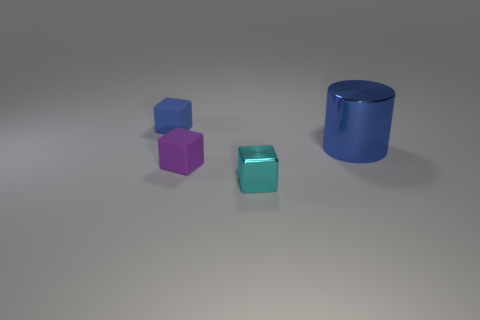The shiny thing that is to the right of the cyan shiny block has what shape?
Keep it short and to the point. Cylinder. Are there any other things that have the same material as the purple object?
Give a very brief answer. Yes. Is the number of purple cubes that are on the left side of the big metallic cylinder greater than the number of blue shiny cylinders?
Your answer should be compact. No. There is a rubber cube in front of the blue object behind the large shiny object; how many tiny rubber things are behind it?
Offer a very short reply. 1. There is a matte block that is in front of the small blue matte thing; does it have the same size as the blue object to the right of the small cyan object?
Your answer should be very brief. No. The blue thing on the left side of the object in front of the small purple rubber object is made of what material?
Offer a terse response. Rubber. How many objects are either cylinders that are behind the small purple rubber block or large metal cylinders?
Keep it short and to the point. 1. Are there the same number of big blue objects on the left side of the small purple block and cyan things behind the shiny cylinder?
Provide a succinct answer. Yes. What material is the object on the left side of the matte thing to the right of the rubber thing that is behind the cylinder made of?
Give a very brief answer. Rubber. How big is the thing that is both right of the purple matte thing and in front of the large thing?
Provide a short and direct response. Small. 